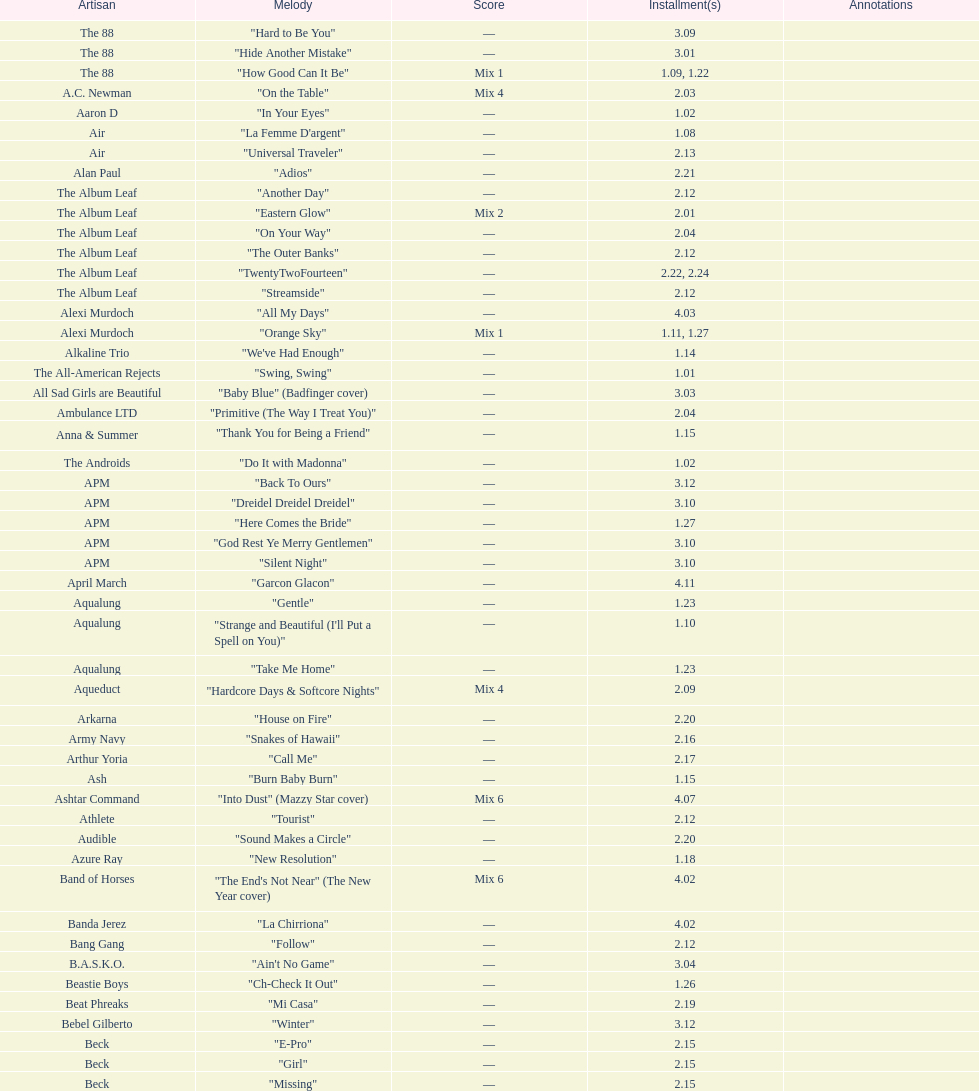How many episodes are below 2.00? 27. 